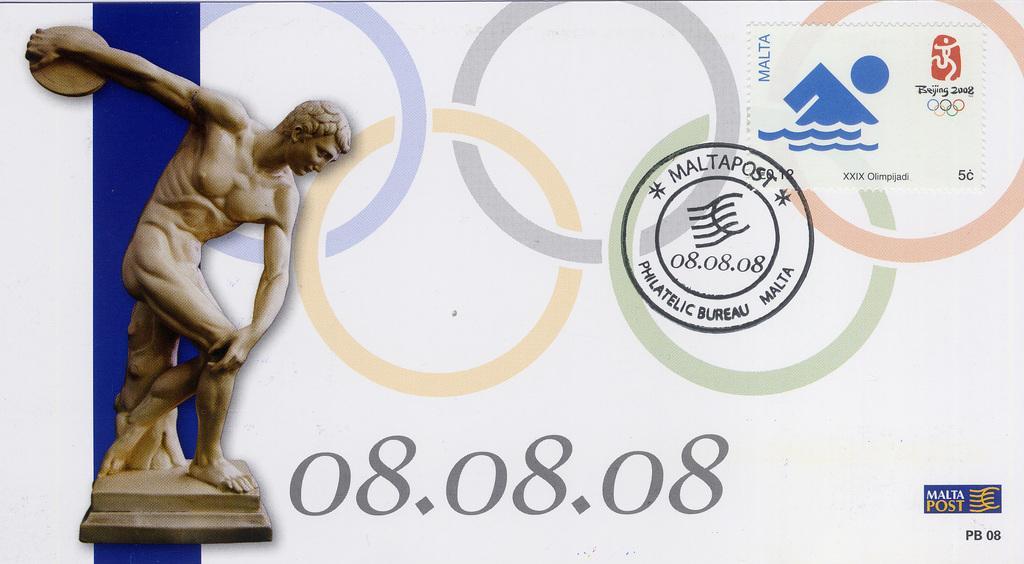Describe this image in one or two sentences. In this image I can see a person sculpture visible on the left side , in the middle I can see a text and design visible. 